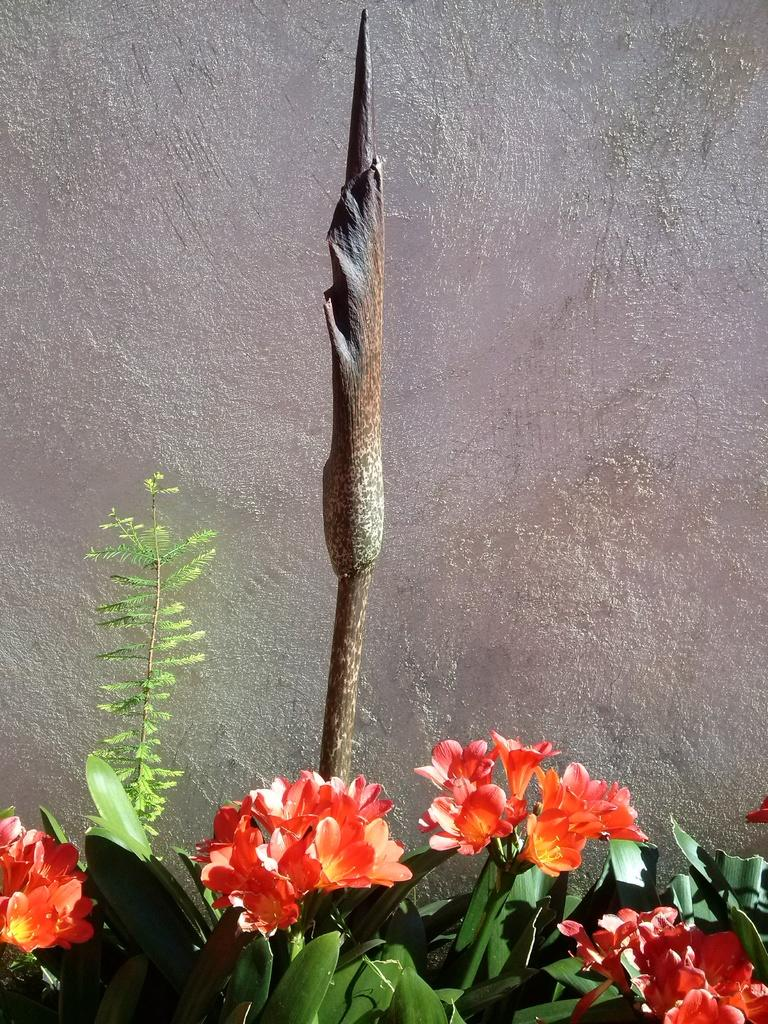What type of plants are present at the bottom of the image? There are plants with orange color flowers at the bottom of the image. What can be seen in the background of the image? There is a wall in the background of the image. What type of camp can be seen in the image? There is no camp present in the image; it features plants with orange color flowers and a wall in the background. Who is the manager of the plants in the image? There is no manager present in the image, as plants do not require human management. 